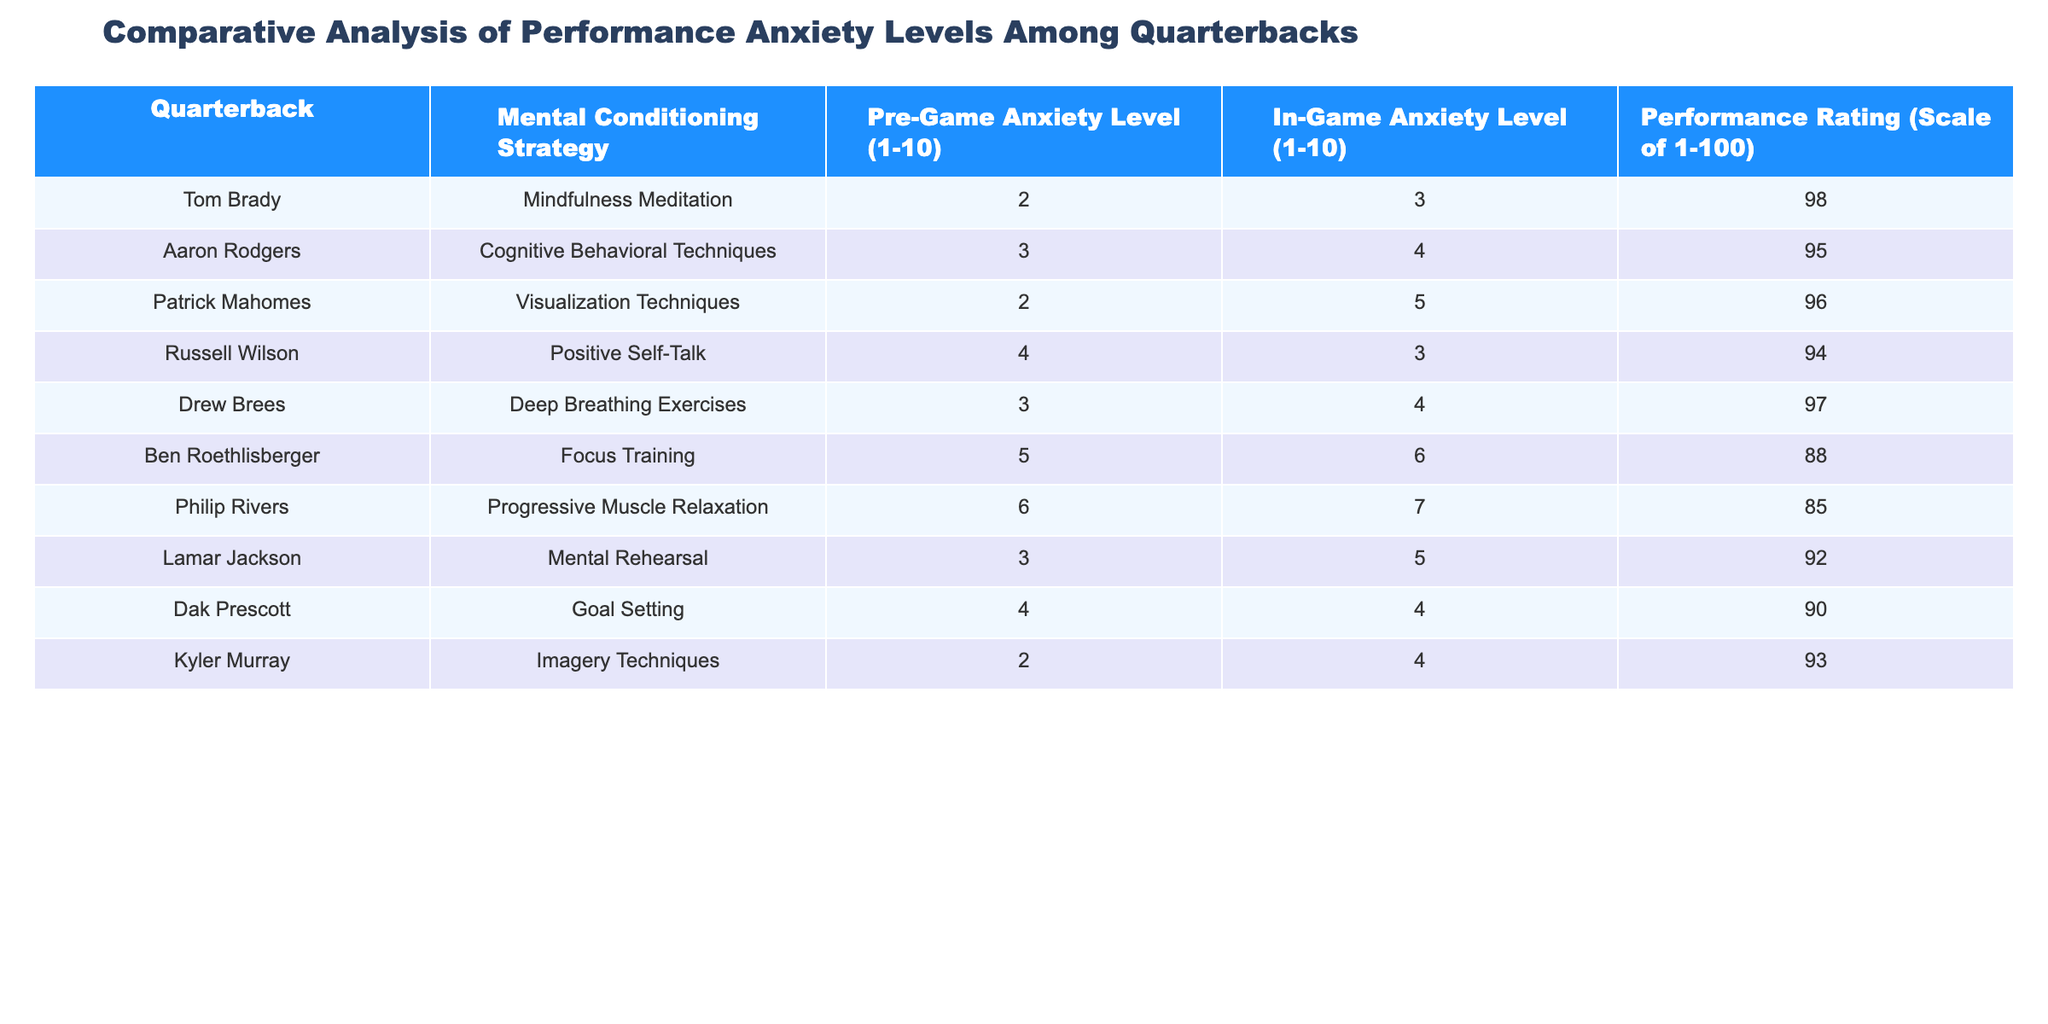What is the performance rating of Tom Brady? The table shows 'Performance Rating' as one of the columns. Looking at the row for Tom Brady, the performance rating is listed as 98.
Answer: 98 Which quarterback had the highest in-game anxiety level? By reviewing the 'In-Game Anxiety Level' column, we find that Philip Rivers has the highest score of 7 in that category.
Answer: 7 What is the average pre-game anxiety level for all quarterbacks? To calculate the average, we sum the pre-game anxiety levels: (2 + 3 + 2 + 4 + 3 + 5 + 6 + 3 + 4 + 2) = 34. There are 10 quarterbacks, so the average is 34 / 10 = 3.4.
Answer: 3.4 Is it true that Drew Brees has a lower in-game anxiety level than Dak Prescott? Comparing the 'In-Game Anxiety Level' for Drew Brees (4) and Dak Prescott (4), they are equal; therefore, the statement is false.
Answer: No Which mental conditioning strategy is associated with the lowest pre-game anxiety level? Inspecting the 'Mental Conditioning Strategy' alongside 'Pre-Game Anxiety Level', both Tom Brady and Patrick Mahomes have the lowest level of 2 with their respective strategies.
Answer: Mindfulness Meditation and Visualization Techniques What is the difference in performance rating between the quarterback with the highest and the lowest rating? The highest performance rating is 98 (Tom Brady) and the lowest is 85 (Philip Rivers). The difference is calculated as 98 - 85 = 13.
Answer: 13 Are the pre-game anxiety levels of quarterbacks using Positive Self-Talk and Mental Rehearsal the same? Checking the 'Pre-Game Anxiety Level' for Russell Wilson (Positive Self-Talk) gives 4, while for Lamar Jackson (Mental Rehearsal) it is 3. Therefore, they are not the same.
Answer: No Who had a performance rating of 94 and which strategy did they use? Looking through the table, we find that Russell Wilson has a performance rating of 94, and he employed Positive Self-Talk as his strategy.
Answer: Russell Wilson, Positive Self-Talk What is the overall trend in performance ratings relative to anxiety levels? Analyzing the data, we observe that lower anxiety levels generally correlate with higher performance ratings, as seen from the extremes in the table.
Answer: Higher performance ratings correlate with lower anxiety levels 